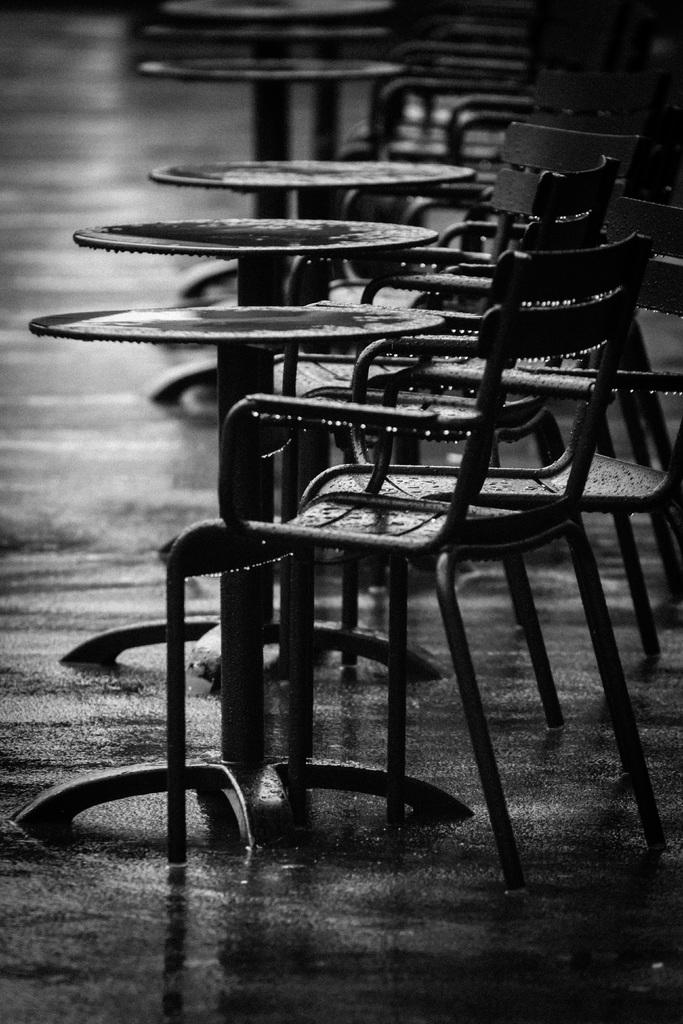What is the color scheme of the image? The image is black and white. What type of furniture can be seen in the image? There are tables and chairs in the image. Can you describe any specific details about the image? There are water droplets visible in the image. What type of hen is sitting on the table in the image? There is no hen present in the image; it is a black and white image with tables and chairs. How many fingers can be seen pointing at the water droplets in the image? There are no fingers visible in the image, as it only features tables, chairs, and water droplets. 